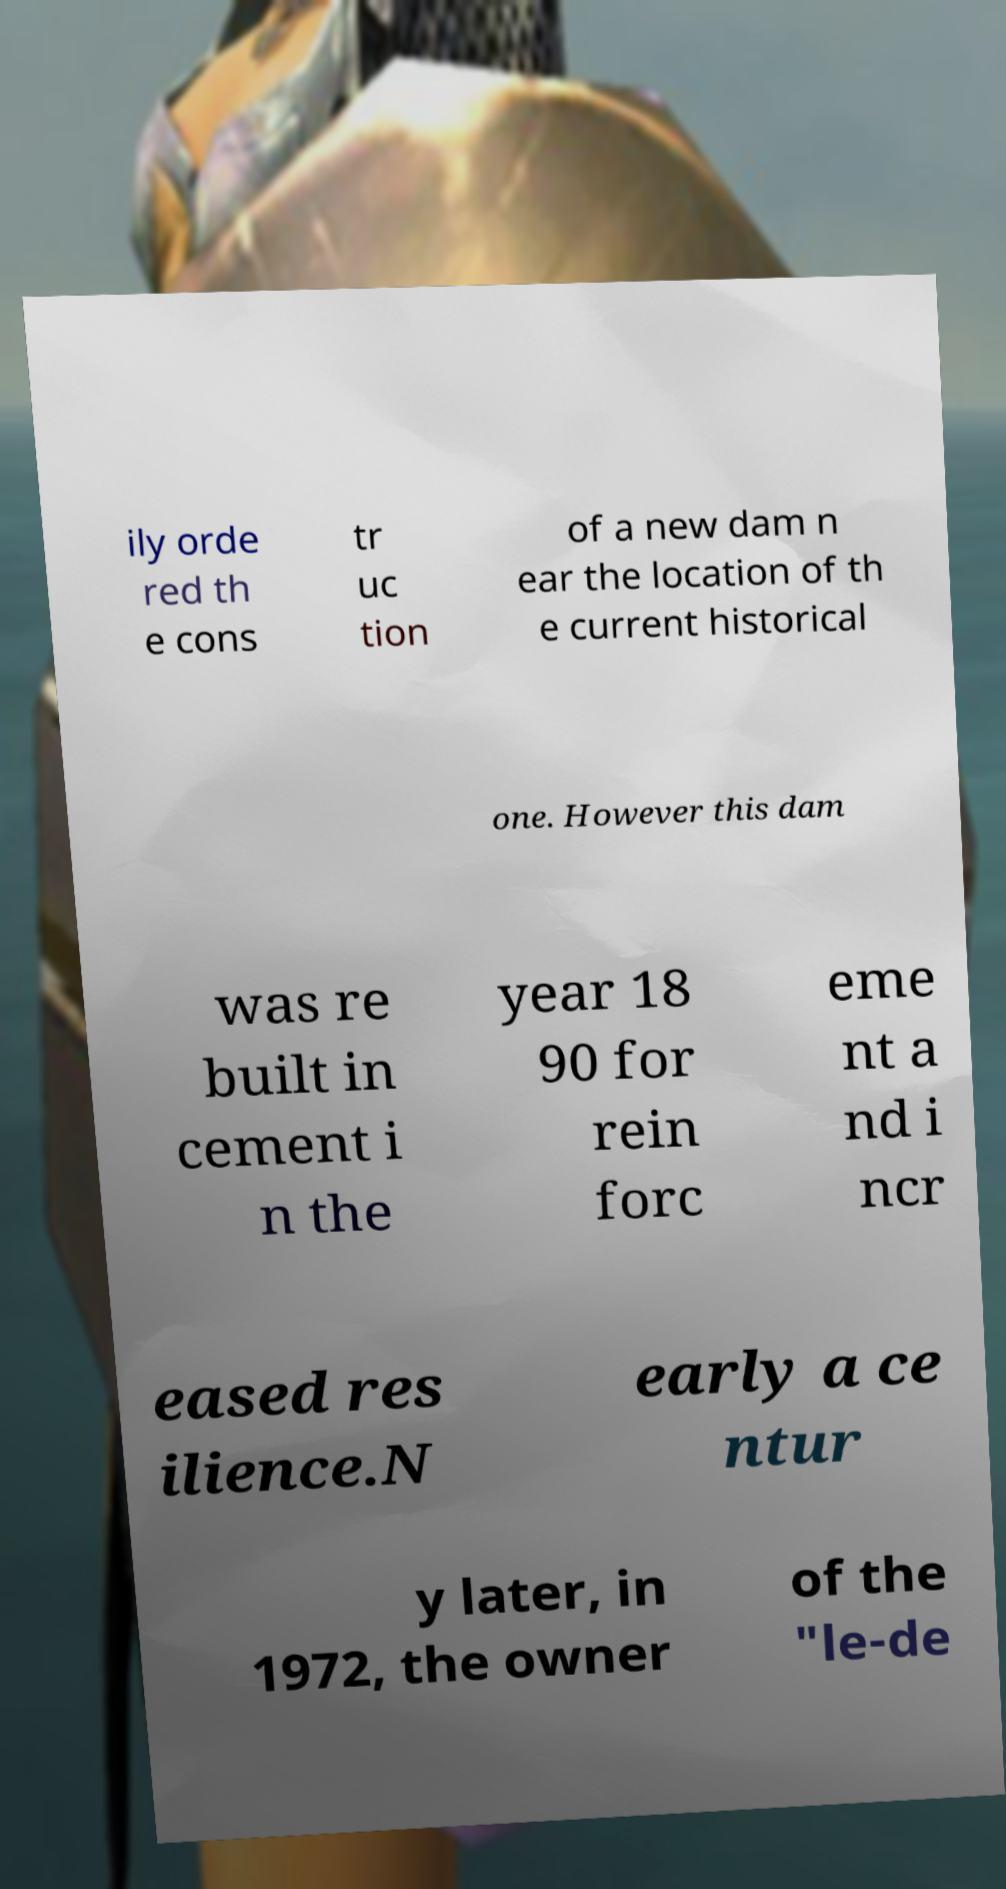Please identify and transcribe the text found in this image. ily orde red th e cons tr uc tion of a new dam n ear the location of th e current historical one. However this dam was re built in cement i n the year 18 90 for rein forc eme nt a nd i ncr eased res ilience.N early a ce ntur y later, in 1972, the owner of the "le-de 